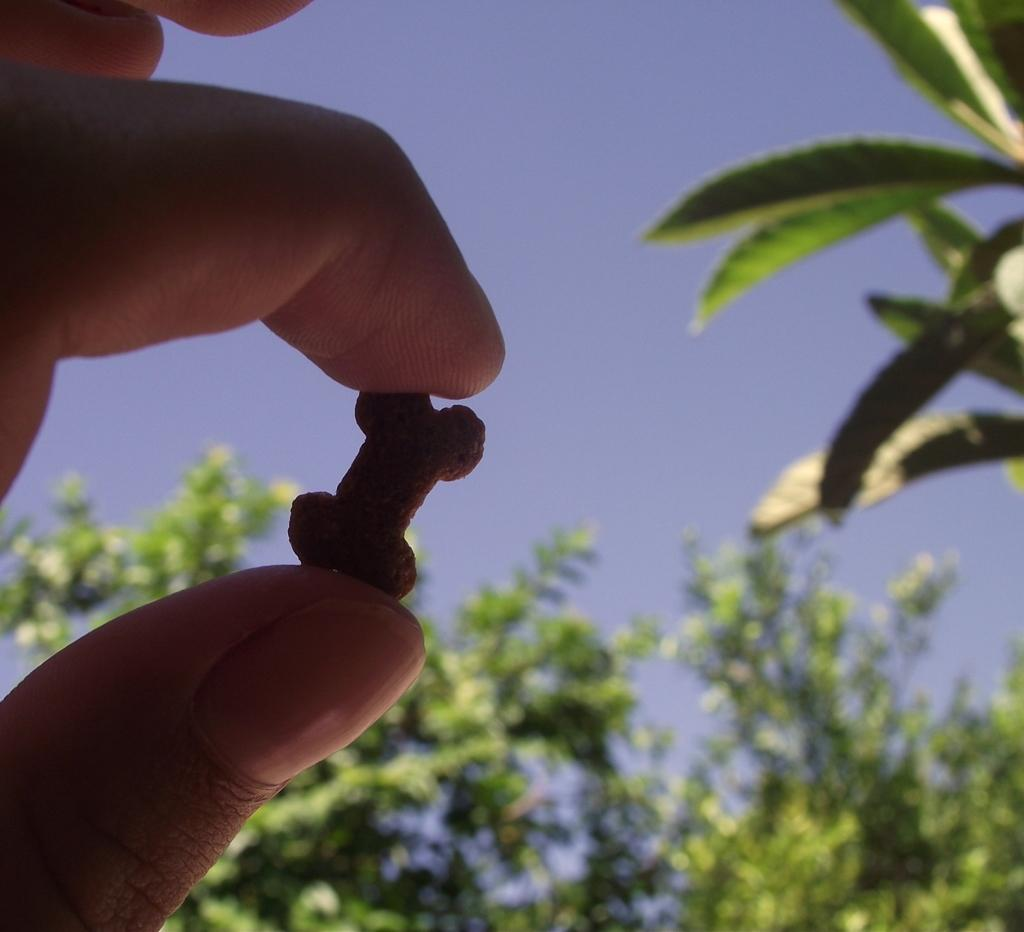What can be seen in the left corner of the image? There are fingers of a person holding an object in the left corner of the image. What can be seen in the background of the image? There are leaves visible in the background of the image. What type of pies can be seen on the table in the image? There is no table or pies present in the image; it only shows fingers holding an object and leaves in the background. 